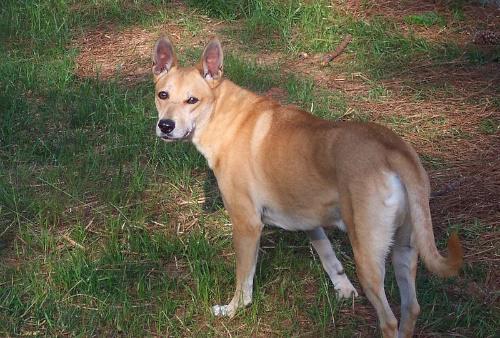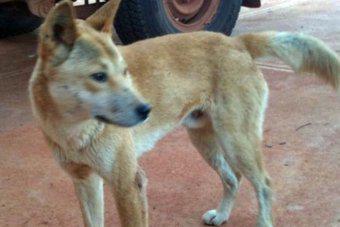The first image is the image on the left, the second image is the image on the right. Evaluate the accuracy of this statement regarding the images: "The dog in the image on the left is laying down on the ground.". Is it true? Answer yes or no. No. The first image is the image on the left, the second image is the image on the right. Assess this claim about the two images: "The left image features one reclining orange dog, and the right image includes at least one standing orange puppy.". Correct or not? Answer yes or no. No. 